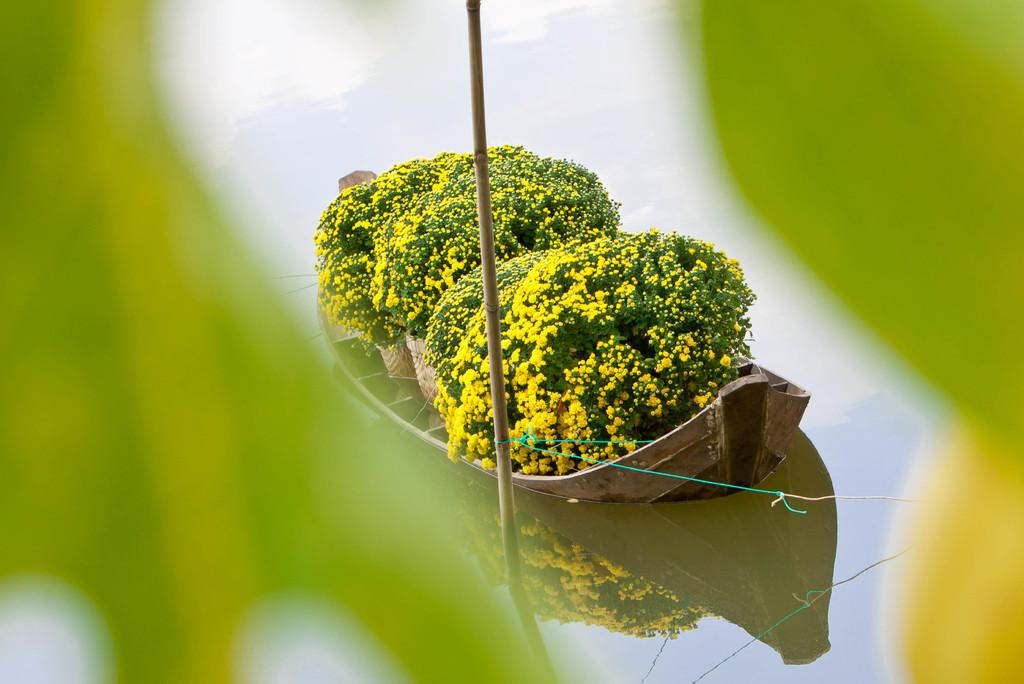What is the main subject in the center of the image? There is a boat in the center of the image. Where is the boat located? The boat is on the water. What can be seen on the boat? There are flower plants on the boat. Can you describe the stem in the center of the image? There is a stem in the center of the image, but it is unclear if it is related to the boat or the flower plants. What type of alarm can be heard going off on the boat in the image? There is no alarm present in the image, and therefore no such sound can be heard. 